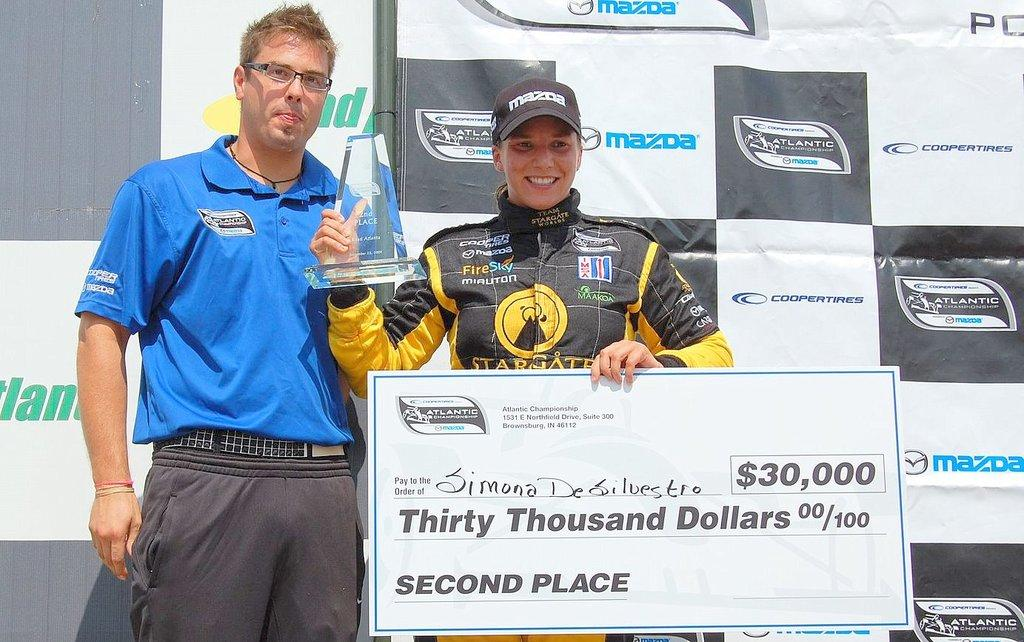<image>
Write a terse but informative summary of the picture. Simona De Silvestro is smiling because she just won $30,000. 